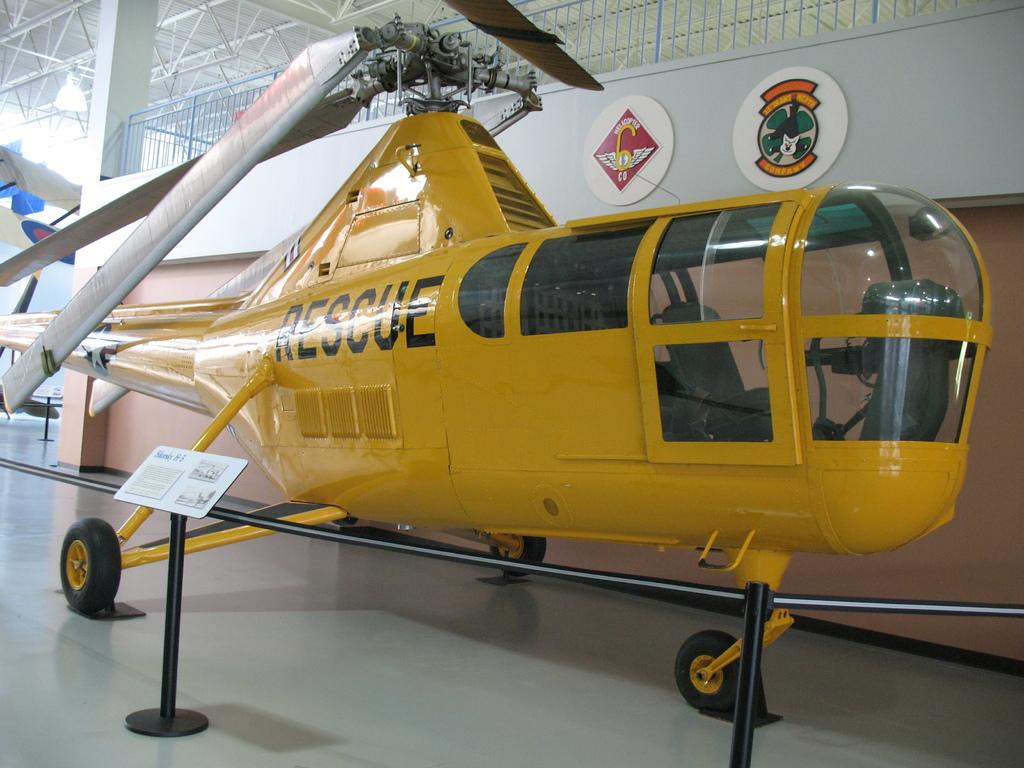<image>
Share a concise interpretation of the image provided. A yellow helicopter has the word rescue on the side of it. 